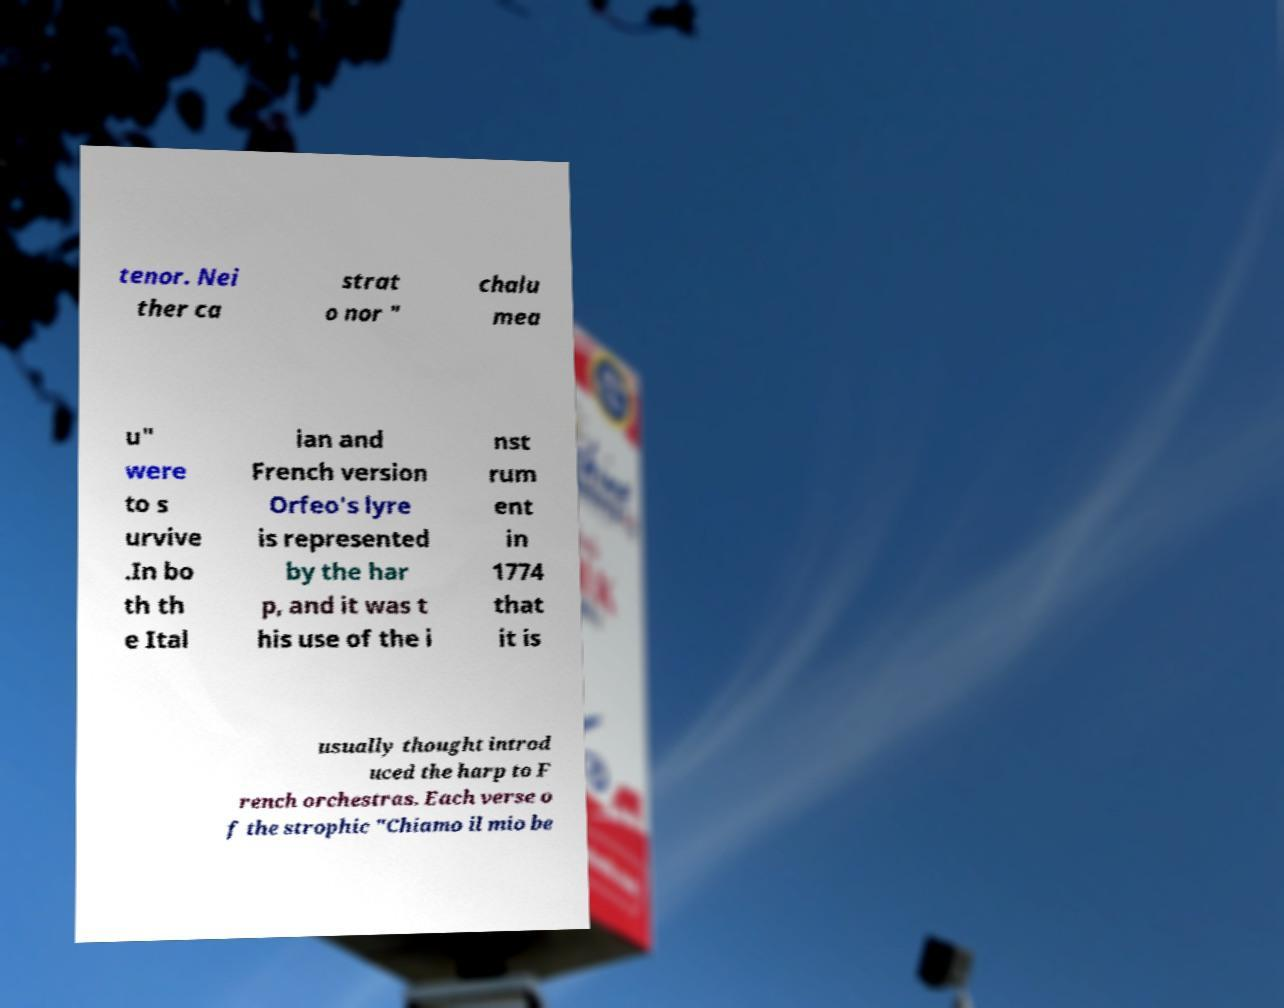Please read and relay the text visible in this image. What does it say? tenor. Nei ther ca strat o nor " chalu mea u" were to s urvive .In bo th th e Ital ian and French version Orfeo's lyre is represented by the har p, and it was t his use of the i nst rum ent in 1774 that it is usually thought introd uced the harp to F rench orchestras. Each verse o f the strophic "Chiamo il mio be 